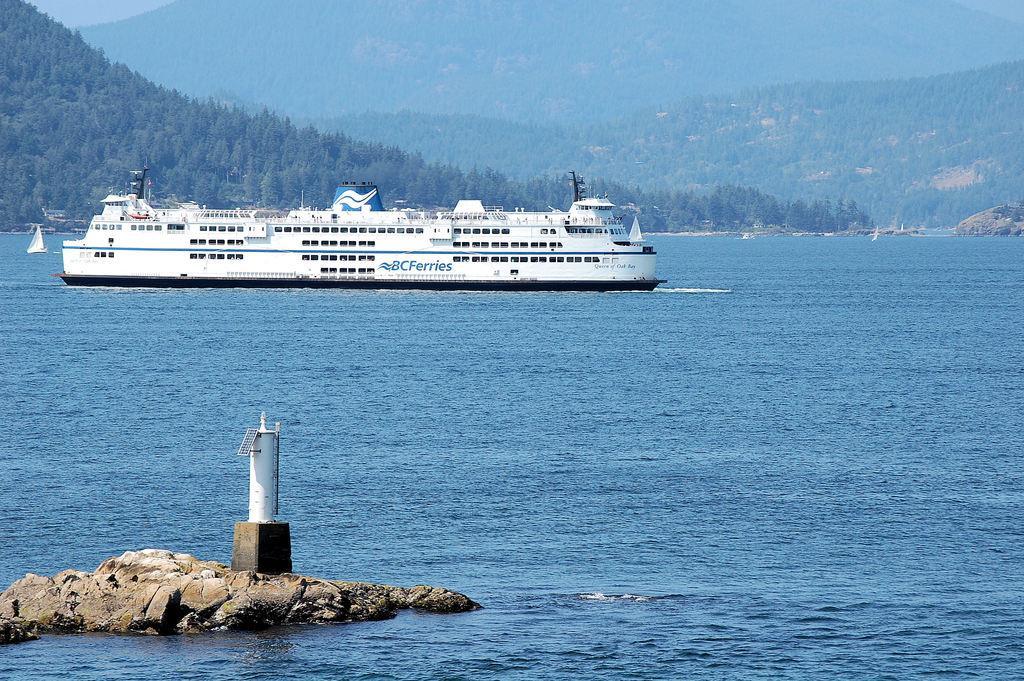How would you summarize this image in a sentence or two? In the image we can see the ship in the water. Here we can see the lighthouse, stones and trees. 